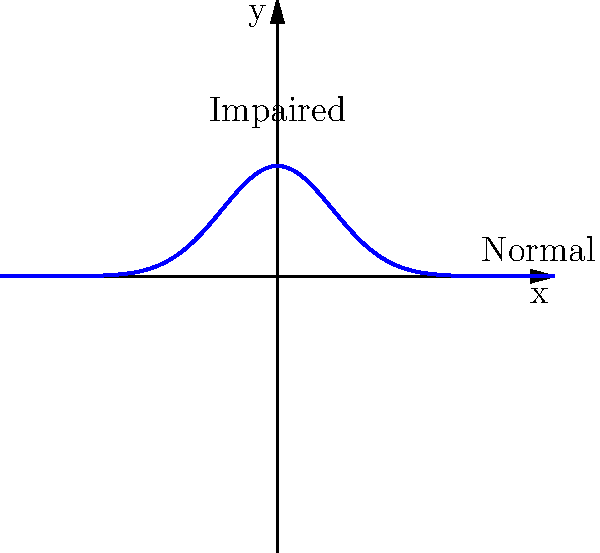As a criminal defense attorney, you're presented with a graph representing fMRI data of cognitive function. The x-axis represents time, and the y-axis represents neural activity. The blue curve shows the typical response pattern. If a client's fMRI data shows a flatter curve with a lower peak, what could this indicate about their cognitive state? How might this information be relevant in a legal context? To interpret this fMRI data and its legal implications, let's break it down step-by-step:

1. Normal cognitive function (blue curve):
   - Shows a sharp peak in neural activity
   - Quickly rises and falls
   - Indicates efficient and responsive cognitive processing

2. Impaired cognitive function (hypothetical flatter curve):
   - Would show a lower peak in neural activity
   - Rise and fall would be less pronounced
   - Suggests slower or less efficient cognitive processing

3. Interpretation of a flatter curve:
   - Could indicate cognitive impairment
   - Possible causes: brain injury, neurodegenerative disease, or substance influence

4. Legal implications:
   - Mental state at the time of the alleged offense
   - Capacity to stand trial
   - Ability to understand Miranda rights
   - Reliability of witness testimony or confessions

5. Defense strategy:
   - Could argue diminished capacity
   - May challenge the admissibility of statements made by the client
   - Might seek alternative sentencing considering cognitive limitations

6. Ethical considerations:
   - Ensure proper interpretation of neuroscientific evidence
   - Consider potential biases in neuroimaging data
   - Balance client advocacy with scientific accuracy

In a legal context, this information could be crucial in arguing for reduced culpability, alternative sentencing, or questioning the validity of the client's actions or statements during the alleged crime or subsequent legal proceedings.
Answer: Cognitive impairment, potentially affecting legal culpability or procedural capacity. 